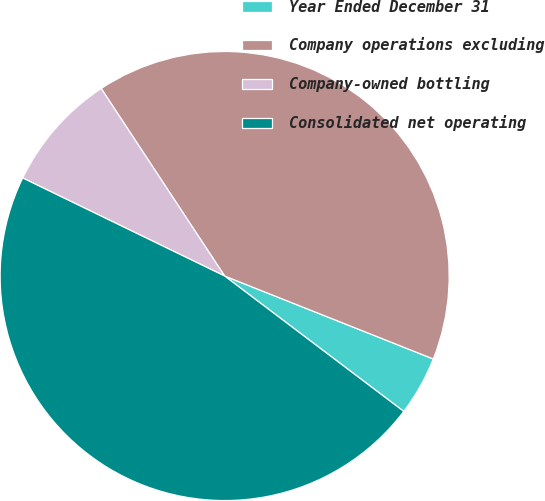Convert chart. <chart><loc_0><loc_0><loc_500><loc_500><pie_chart><fcel>Year Ended December 31<fcel>Company operations excluding<fcel>Company-owned bottling<fcel>Consolidated net operating<nl><fcel>4.28%<fcel>40.29%<fcel>8.54%<fcel>46.89%<nl></chart> 